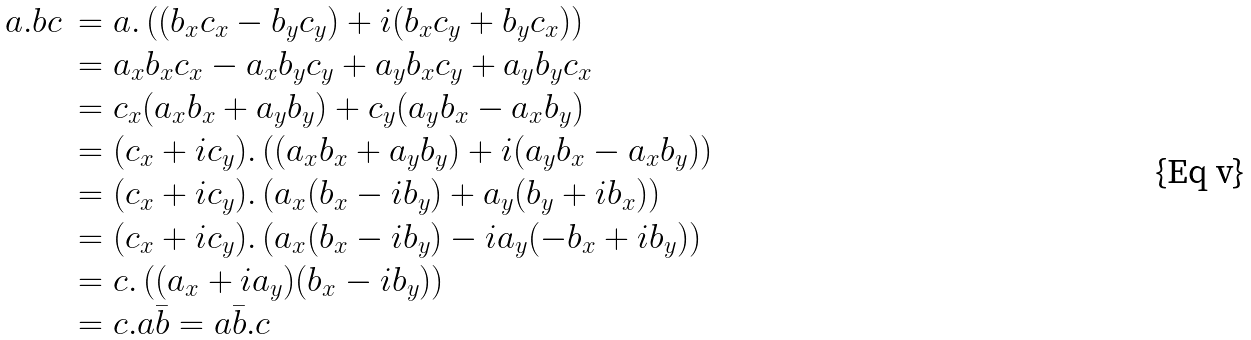<formula> <loc_0><loc_0><loc_500><loc_500>\begin{array} { l l } a . b c & = a . \left ( ( b _ { x } c _ { x } - b _ { y } c _ { y } ) + i ( b _ { x } c _ { y } + b _ { y } c _ { x } ) \right ) \\ & = a _ { x } b _ { x } c _ { x } - a _ { x } b _ { y } c _ { y } + a _ { y } b _ { x } c _ { y } + a _ { y } b _ { y } c _ { x } \\ & = c _ { x } ( a _ { x } b _ { x } + a _ { y } b _ { y } ) + c _ { y } ( a _ { y } b _ { x } - a _ { x } b _ { y } ) \\ & = ( c _ { x } + i c _ { y } ) . \left ( ( a _ { x } b _ { x } + a _ { y } b _ { y } ) + i ( a _ { y } b _ { x } - a _ { x } b _ { y } ) \right ) \\ & = ( c _ { x } + i c _ { y } ) . \left ( a _ { x } ( b _ { x } - i b _ { y } ) + a _ { y } ( b _ { y } + i b _ { x } ) \right ) \\ & = ( c _ { x } + i c _ { y } ) . \left ( a _ { x } ( b _ { x } - i b _ { y } ) - i a _ { y } ( - b _ { x } + i b _ { y } ) \right ) \\ & = c . \left ( ( a _ { x } + i a _ { y } ) ( b _ { x } - i b _ { y } ) \right ) \\ & = c . a \bar { b } = a \bar { b } . c \end{array}</formula> 